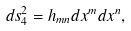<formula> <loc_0><loc_0><loc_500><loc_500>d s ^ { 2 } _ { 4 } = h _ { m n } d x ^ { m } d x ^ { n } ,</formula> 